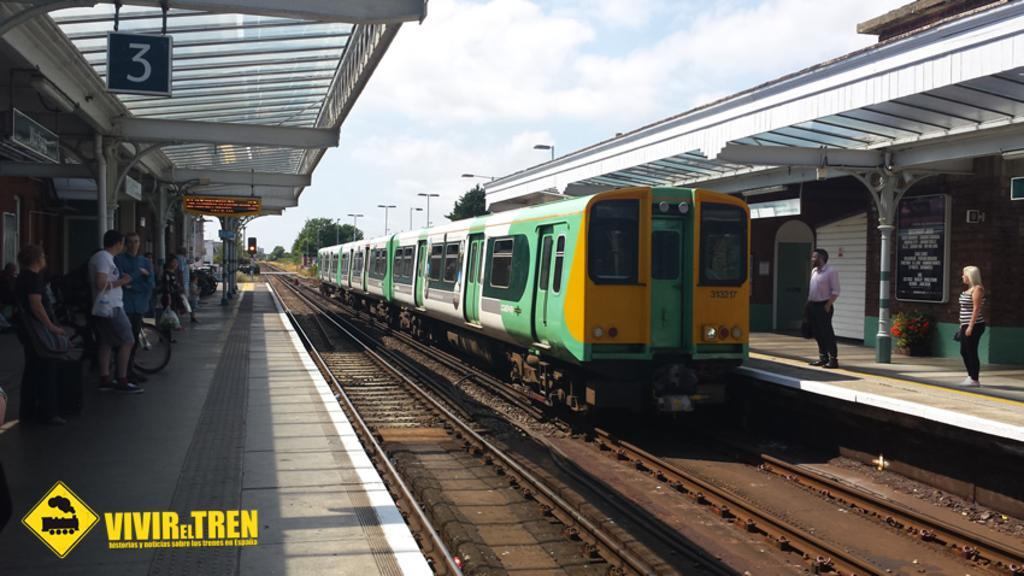Provide a one-sentence caption for the provided image. Vivir el Tren features train histories, notes, and trains at train stations. 